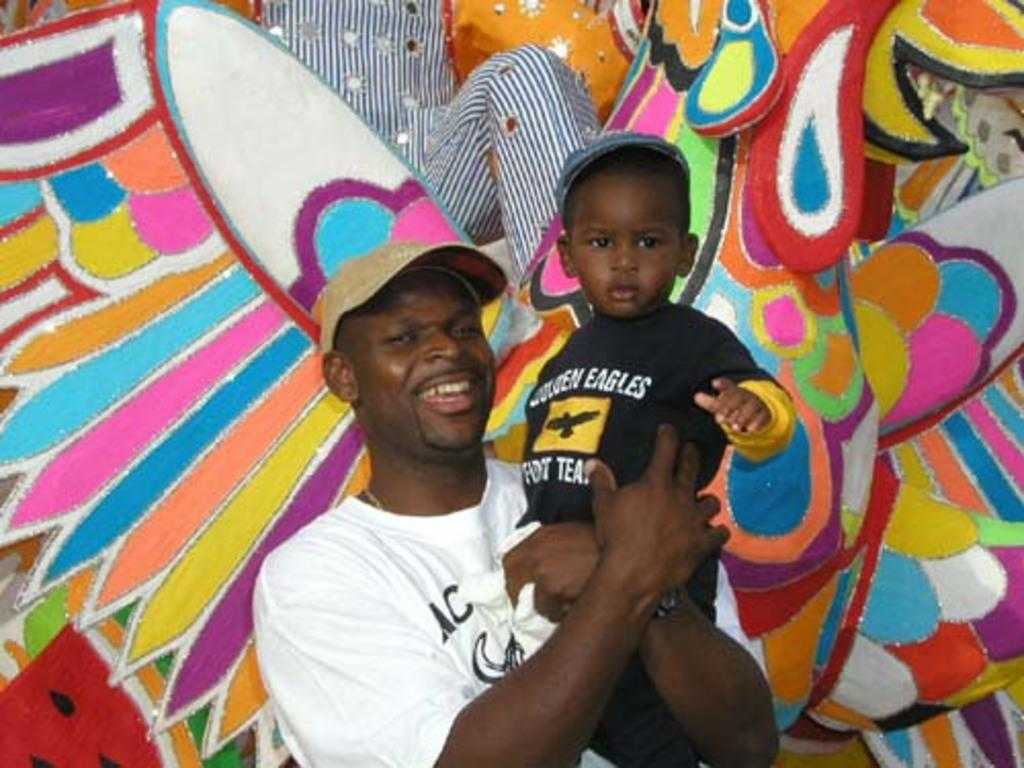<image>
Relay a brief, clear account of the picture shown. A child wearing a black shirt that says Golden Eagles. 